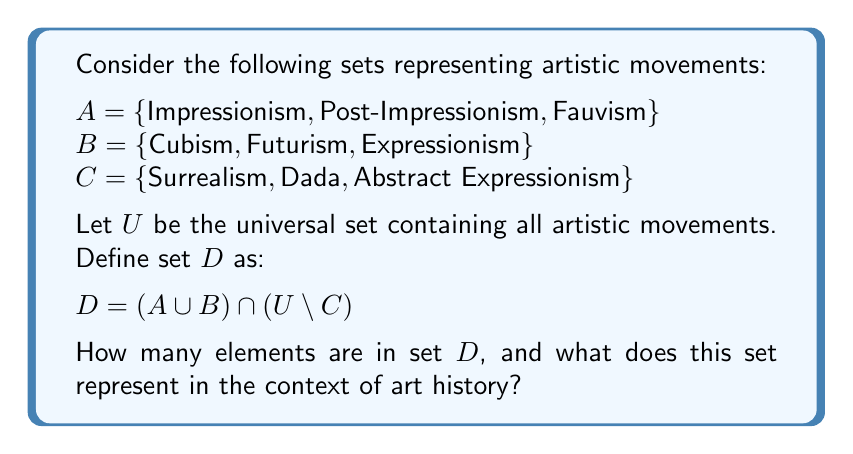Solve this math problem. To solve this problem, we need to follow these steps:

1) First, let's understand what each set represents:
   $A$: Early modern art movements
   $B$: Early 20th century avant-garde movements
   $C$: Mid-20th century movements

2) Now, let's break down the definition of set $D$:
   $D = (A \cup B) \cap (U \setminus C)$

3) $A \cup B$ represents all elements in $A$ and $B$:
   $A \cup B = \{\text{Impressionism}, \text{Post-Impressionism}, \text{Fauvism}, \text{Cubism}, \text{Futurism}, \text{Expressionism}\}$

4) $U \setminus C$ represents all elements in the universal set $U$ that are not in $C$. This includes all artistic movements except Surrealism, Dada, and Abstract Expressionism.

5) The intersection of $(A \cup B)$ and $(U \setminus C)$ will give us all elements that are in both sets. Since all elements of $A$ and $B$ are not in $C$, the intersection will simply be all elements of $A \cup B$.

6) Therefore, $D = A \cup B$, which contains 6 elements.

In the context of art history, set $D$ represents early modern and early 20th century avant-garde movements that predate the mid-20th century movements represented by set $C$. This set captures a significant period of artistic innovation and experimentation, spanning from the late 19th century to the early 20th century.
Answer: Set $D$ contains 6 elements. It represents early modern and early 20th century avant-garde artistic movements, specifically Impressionism, Post-Impressionism, Fauvism, Cubism, Futurism, and Expressionism. 